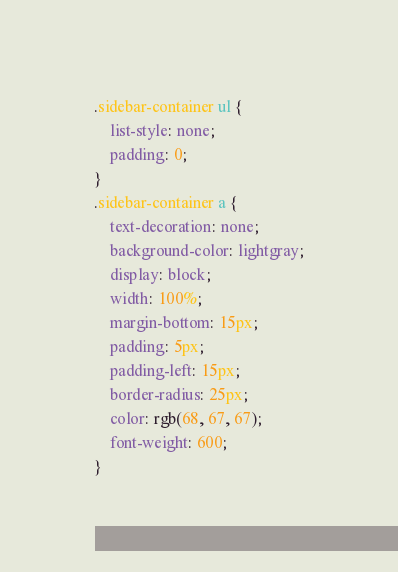Convert code to text. <code><loc_0><loc_0><loc_500><loc_500><_CSS_>
.sidebar-container ul {
    list-style: none;
    padding: 0;
}
.sidebar-container a {
    text-decoration: none;
    background-color: lightgray;
    display: block;
    width: 100%;
    margin-bottom: 15px;
    padding: 5px;
    padding-left: 15px;
    border-radius: 25px;
    color: rgb(68, 67, 67);
    font-weight: 600;
}</code> 